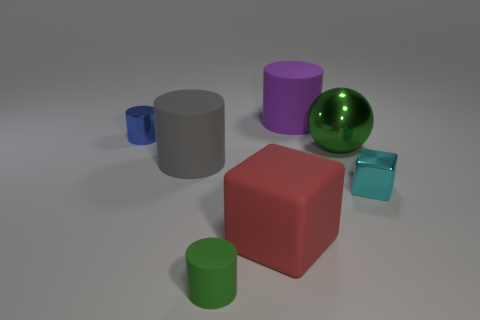Does the large metal thing have the same color as the shiny object on the left side of the big purple cylinder?
Your answer should be very brief. No. Is there any other thing that is the same size as the gray cylinder?
Give a very brief answer. Yes. There is a cube on the left side of the small shiny object that is on the right side of the big green metallic sphere; what is its size?
Offer a terse response. Large. How many objects are either cylinders or small objects that are to the left of the small block?
Ensure brevity in your answer.  4. Does the green object in front of the shiny block have the same shape as the purple matte thing?
Give a very brief answer. Yes. What number of metallic spheres are in front of the tiny metallic object that is in front of the big matte cylinder that is in front of the large shiny ball?
Offer a terse response. 0. Is there anything else that is the same shape as the big purple rubber object?
Offer a very short reply. Yes. How many objects are red rubber cylinders or large gray rubber things?
Your answer should be compact. 1. Is the shape of the purple thing the same as the shiny object that is on the left side of the purple cylinder?
Offer a terse response. Yes. There is a green object that is in front of the tiny cyan cube; what is its shape?
Provide a short and direct response. Cylinder. 